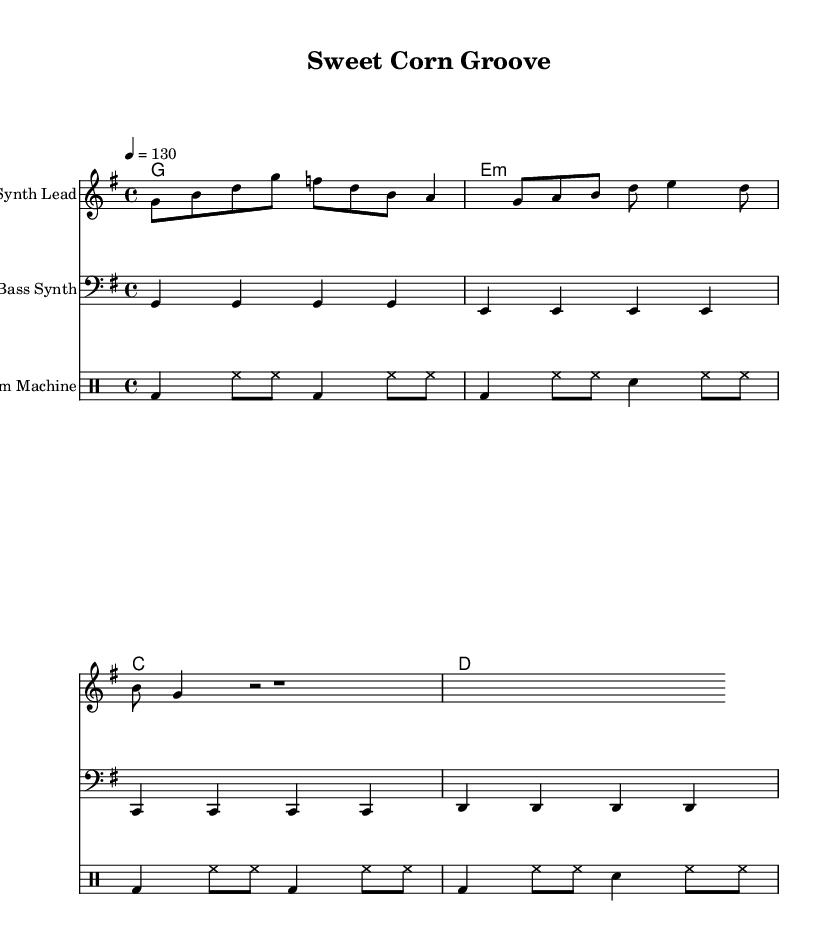What is the key signature of this music? The key signature is indicated at the beginning of the piece, where there is one sharp (F#) present. This confirms that the key signature is G major.
Answer: G major What is the time signature of this music? The time signature is located after the key signature at the beginning of the music. It shows "4/4", which means there are four beats in each measure and the quarter note gets one beat.
Answer: 4/4 What is the tempo marking in this music? The tempo marking appears at the beginning of the score and is indicated by the number "130" after the note value "4 =". This means 130 beats per minute.
Answer: 130 How many measures are in the synth lead section? By counting the individual sections or phrases in the synth lead part, we see there are 4 measures present.
Answer: 4 Which instrument plays the bass synth part? The instrument name is specified in the score, and it is clearly written as "Bass Synth" under the staff, indicating that this part is for the bass synth instrument.
Answer: Bass Synth What types of voices are featured in the harmony section? The harmony section lists chord names as follows: G, E minor, C, D. This shows the harmonic structure involves these specific chords related to the key signature.
Answer: G, E minor, C, D What is the beat pattern for the drum machine? The drum machine section displays a repeated pattern of bass drum and hi-hat in eighth notes, and snare drum, showing the rhythm structure typical for electronic dance music.
Answer: Bass drum and hi-hat pattern with snare 